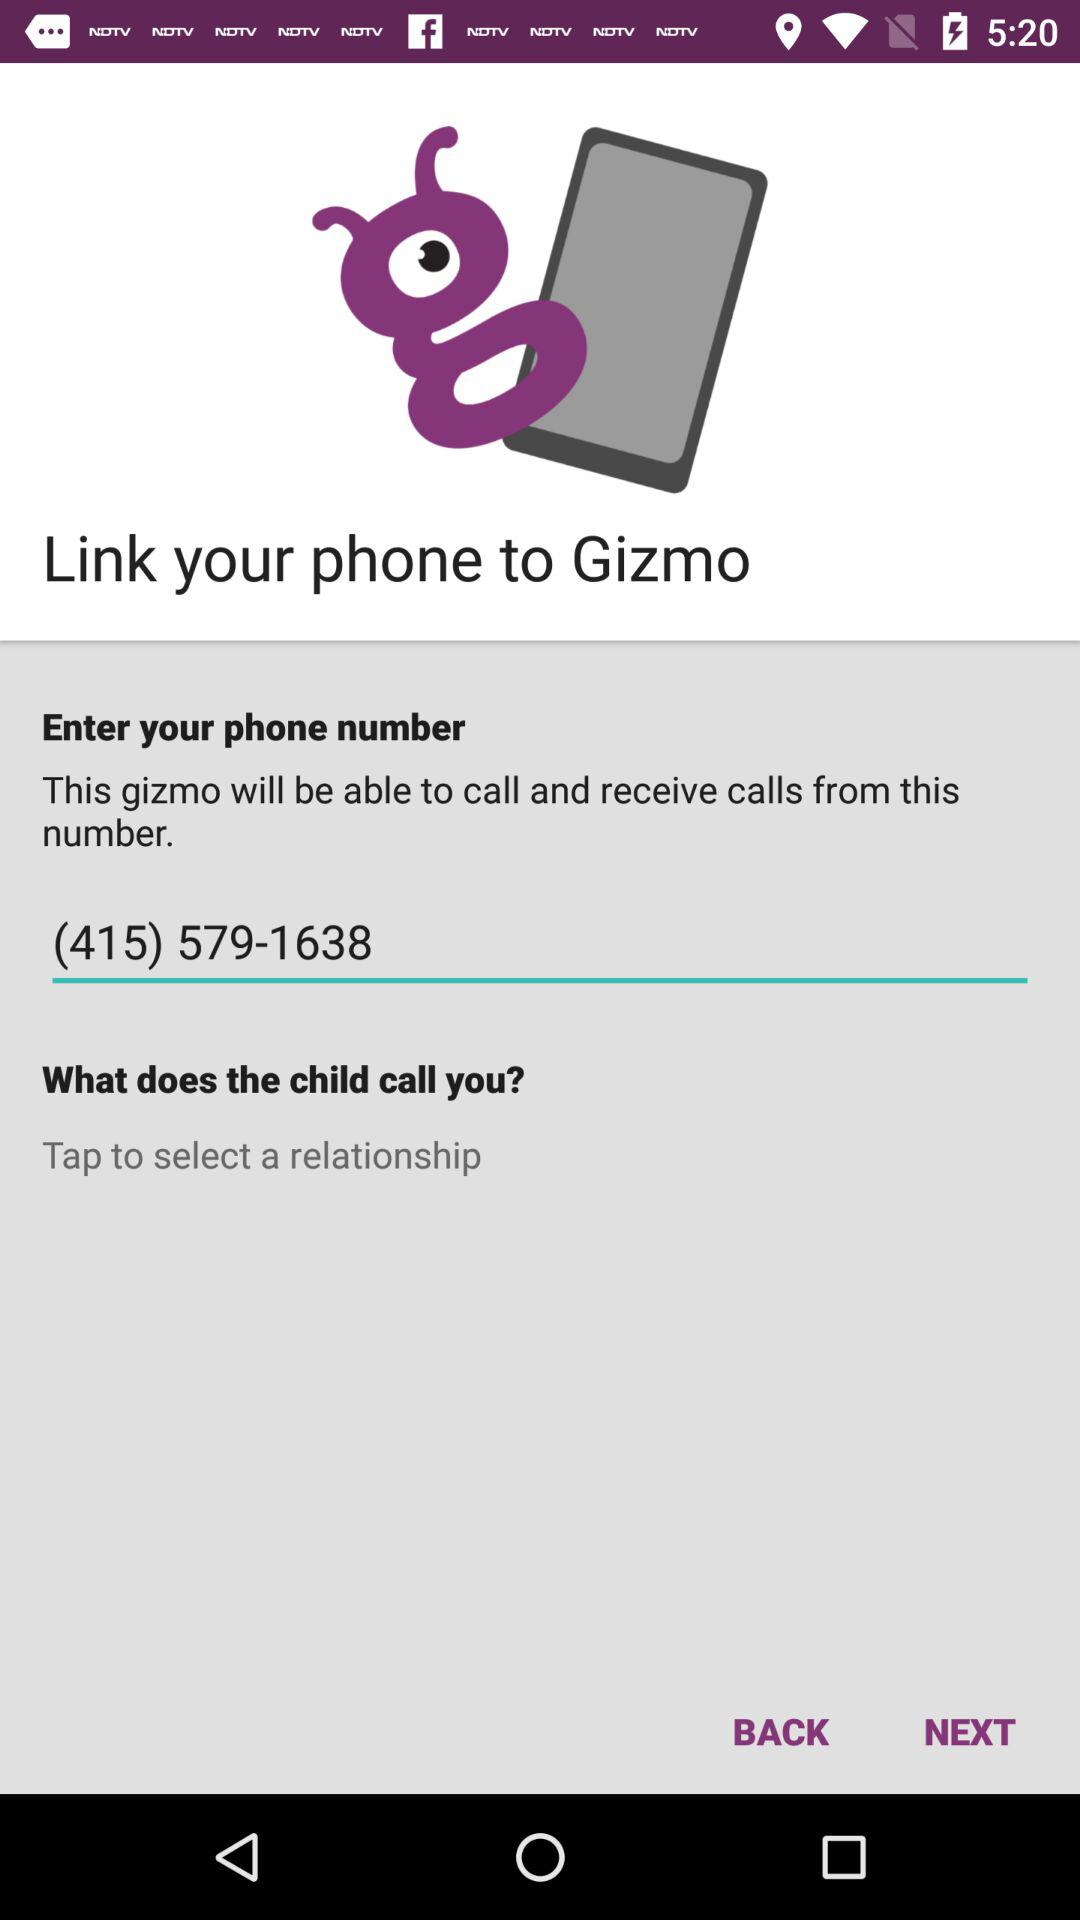What is the phone number? The phone number is (415) 579-1638. 